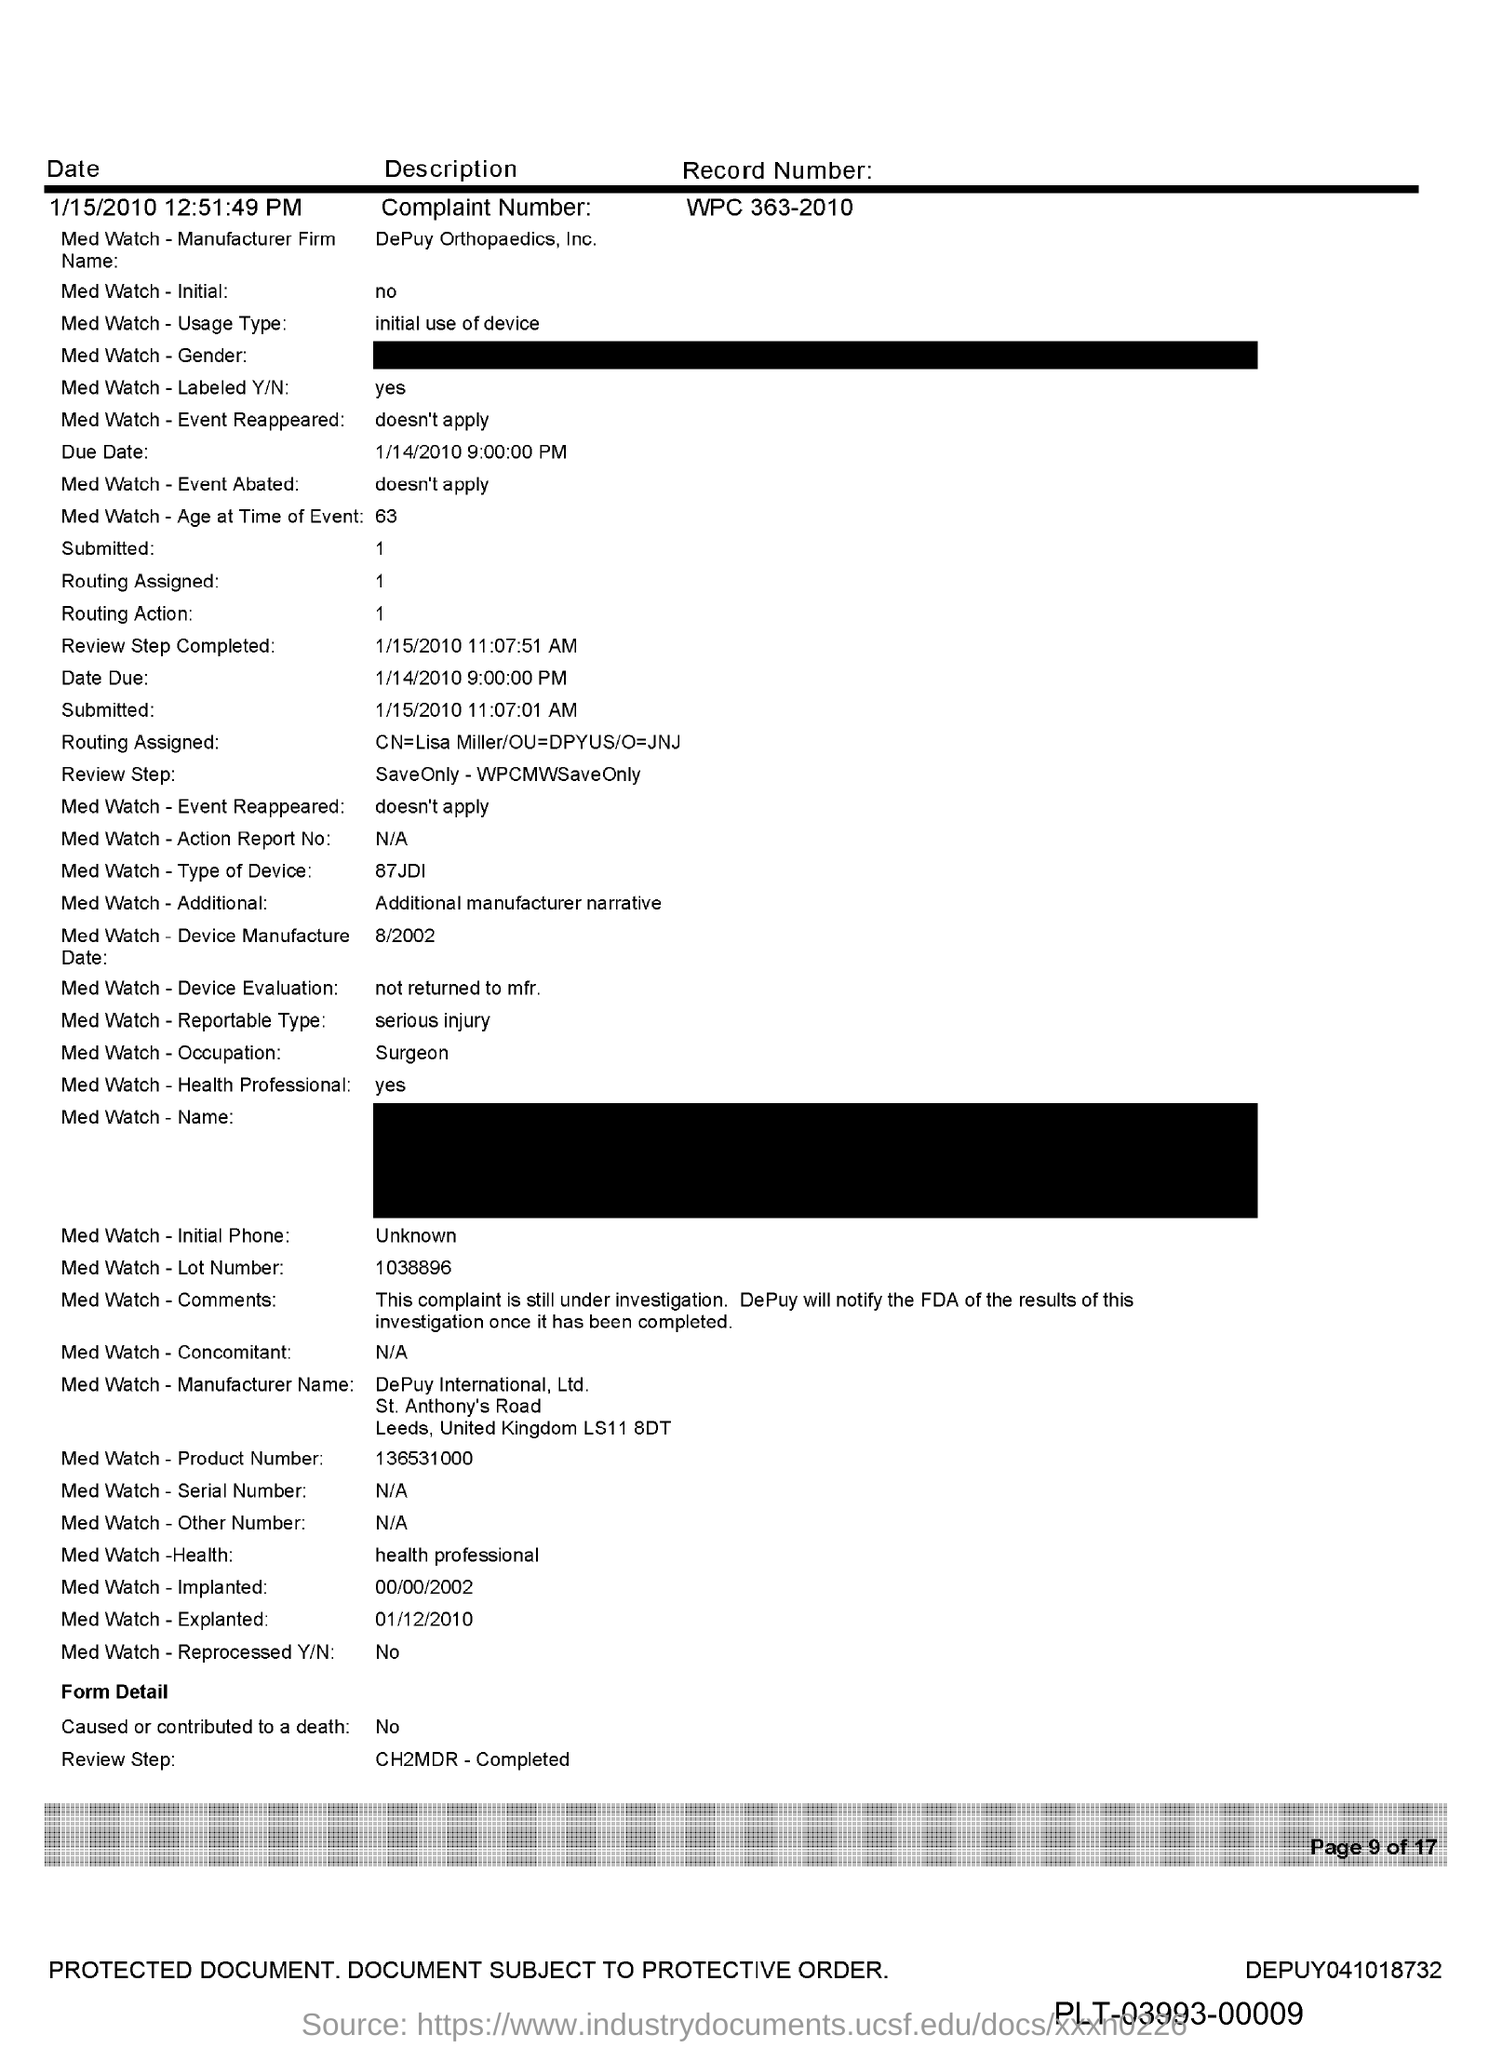Outline some significant characteristics in this image. The complaint number is WPC 363-2010. 